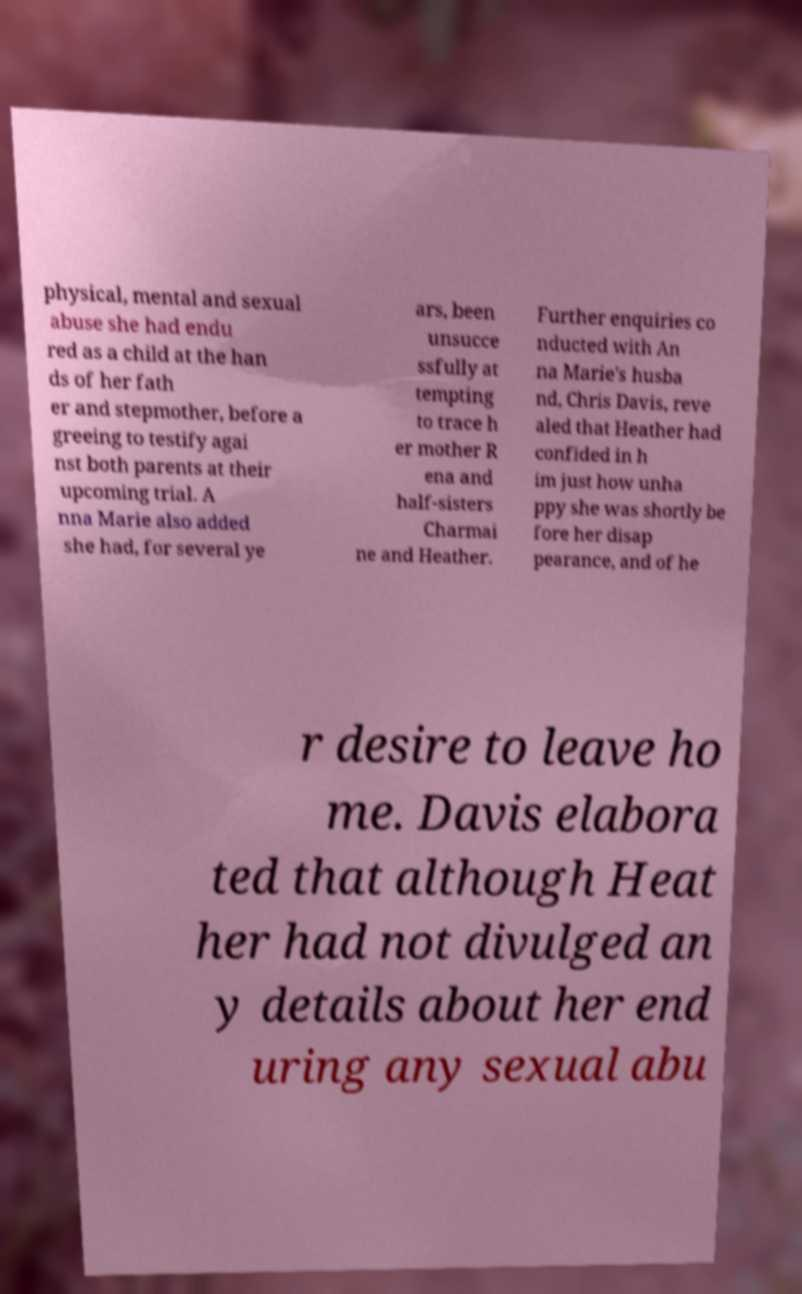Please identify and transcribe the text found in this image. physical, mental and sexual abuse she had endu red as a child at the han ds of her fath er and stepmother, before a greeing to testify agai nst both parents at their upcoming trial. A nna Marie also added she had, for several ye ars, been unsucce ssfully at tempting to trace h er mother R ena and half-sisters Charmai ne and Heather. Further enquiries co nducted with An na Marie's husba nd, Chris Davis, reve aled that Heather had confided in h im just how unha ppy she was shortly be fore her disap pearance, and of he r desire to leave ho me. Davis elabora ted that although Heat her had not divulged an y details about her end uring any sexual abu 